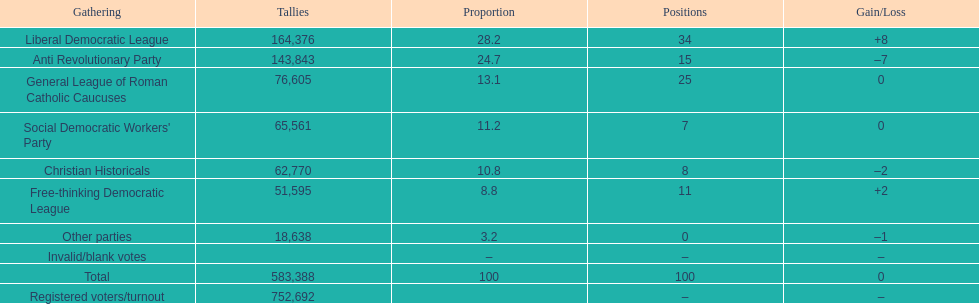After the election, how many seats did the liberal democratic league win? 34. 